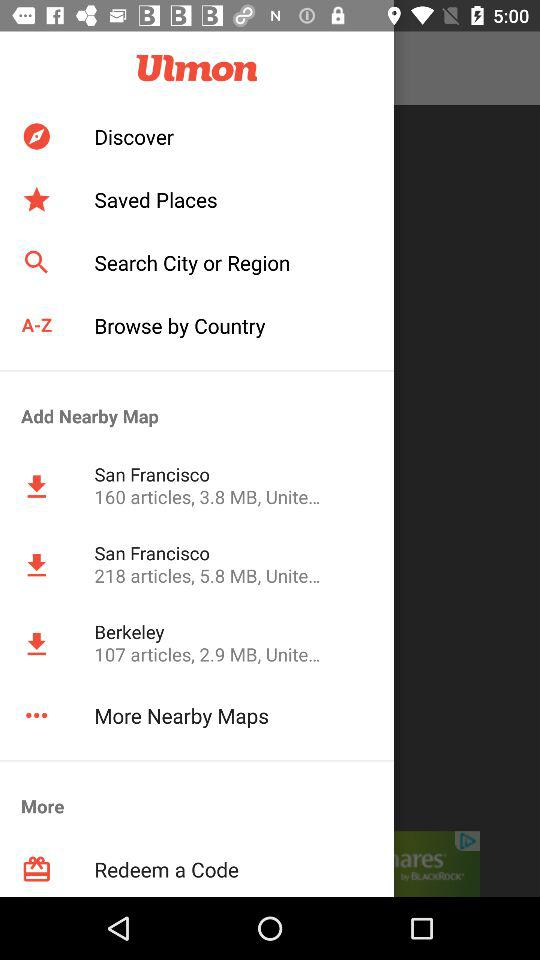How many maps are shown in the More Nearby Maps section?
Answer the question using a single word or phrase. 3 